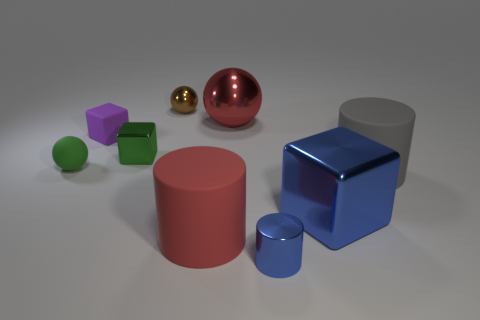How many objects are either matte things that are on the right side of the large red metal object or small green matte things?
Offer a very short reply. 2. There is a red shiny thing that is the same size as the gray matte thing; what is its shape?
Your response must be concise. Sphere. There is a block in front of the green rubber ball; is its size the same as the gray cylinder behind the red rubber cylinder?
Your answer should be compact. Yes. What is the color of the tiny block that is the same material as the big red cylinder?
Make the answer very short. Purple. Are the cube to the right of the red shiny object and the cylinder in front of the red cylinder made of the same material?
Your response must be concise. Yes. Is there a cylinder that has the same size as the gray thing?
Make the answer very short. Yes. What is the size of the metallic cube that is to the left of the metallic block that is to the right of the brown ball?
Offer a very short reply. Small. What number of large matte things have the same color as the big block?
Your answer should be compact. 0. The red object that is on the right side of the big rubber thing in front of the big gray thing is what shape?
Provide a succinct answer. Sphere. How many cubes have the same material as the large ball?
Provide a short and direct response. 2. 